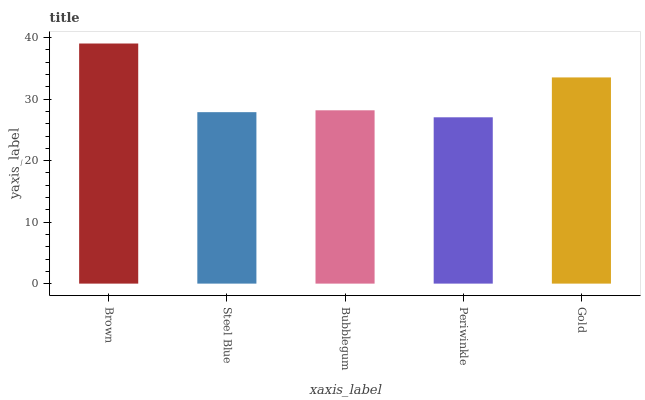Is Periwinkle the minimum?
Answer yes or no. Yes. Is Brown the maximum?
Answer yes or no. Yes. Is Steel Blue the minimum?
Answer yes or no. No. Is Steel Blue the maximum?
Answer yes or no. No. Is Brown greater than Steel Blue?
Answer yes or no. Yes. Is Steel Blue less than Brown?
Answer yes or no. Yes. Is Steel Blue greater than Brown?
Answer yes or no. No. Is Brown less than Steel Blue?
Answer yes or no. No. Is Bubblegum the high median?
Answer yes or no. Yes. Is Bubblegum the low median?
Answer yes or no. Yes. Is Brown the high median?
Answer yes or no. No. Is Steel Blue the low median?
Answer yes or no. No. 